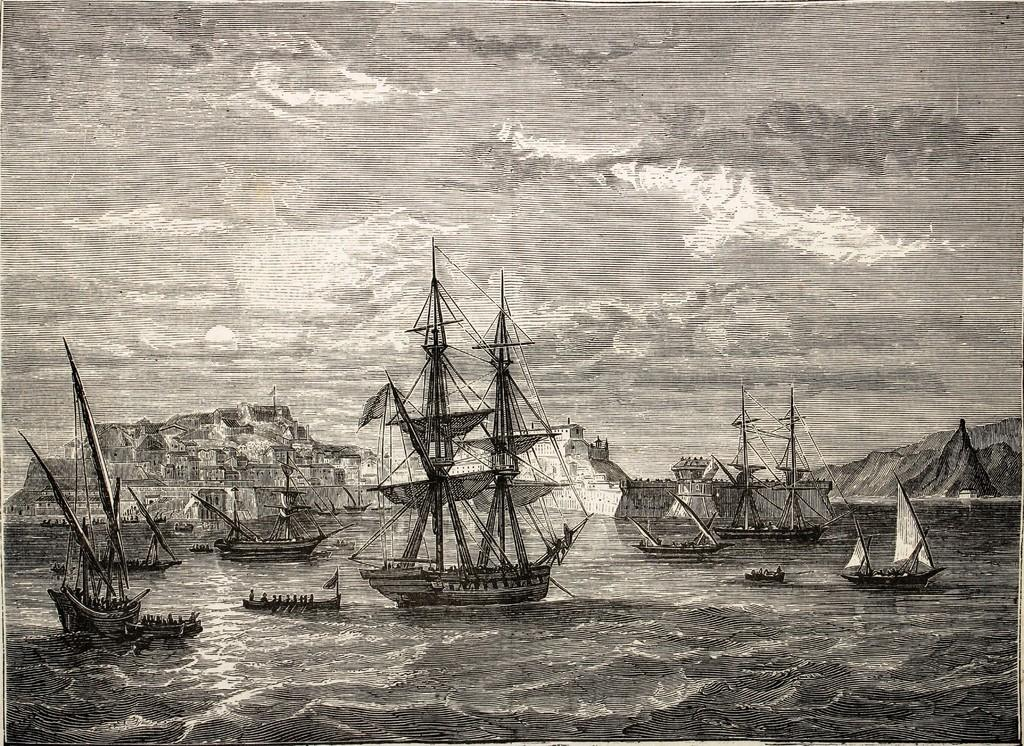What is the main subject of the sketch drawing in the image? The main subject of the sketch drawing is water. What can be seen in the water in the sketch drawing? There are boats in the sketch drawing of water. What other elements are present in the image besides the sketch drawing? There is a hill with houses visible in the image. What is visible in the background of the image? The sky is visible in the background of the image, with clouds present. How many horses are grazing on the wool in the image? There are no horses or wool present in the image; it features a sketch drawing of water with boats, a hill with houses, and a sky with clouds. 